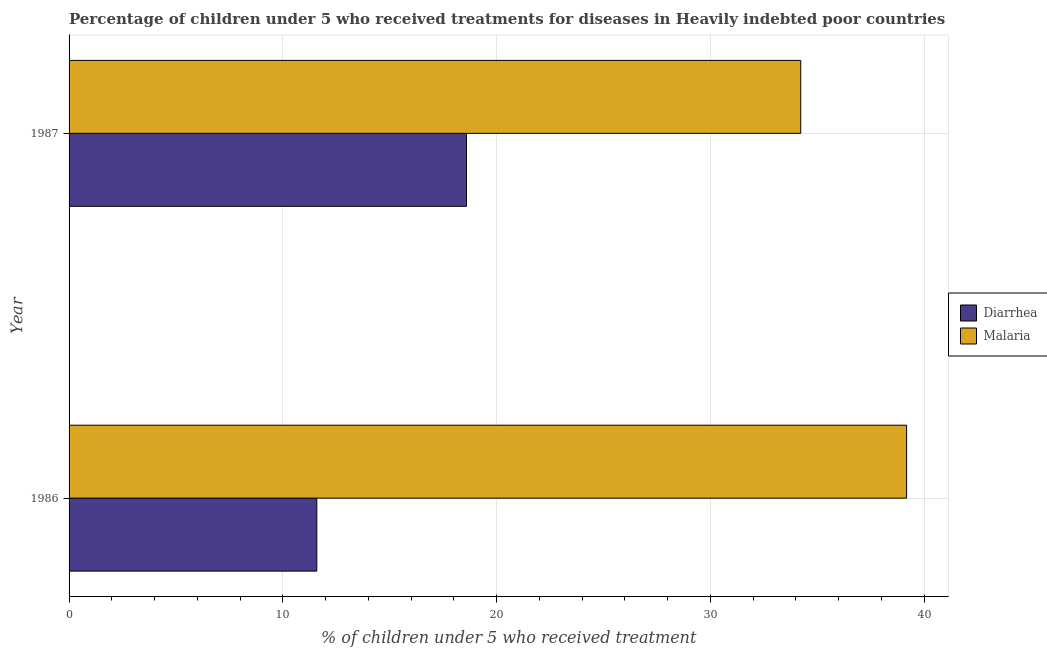How many different coloured bars are there?
Give a very brief answer. 2. How many groups of bars are there?
Make the answer very short. 2. Are the number of bars per tick equal to the number of legend labels?
Keep it short and to the point. Yes. Are the number of bars on each tick of the Y-axis equal?
Make the answer very short. Yes. How many bars are there on the 2nd tick from the top?
Keep it short and to the point. 2. In how many cases, is the number of bars for a given year not equal to the number of legend labels?
Your answer should be compact. 0. What is the percentage of children who received treatment for diarrhoea in 1987?
Your answer should be very brief. 18.59. Across all years, what is the maximum percentage of children who received treatment for malaria?
Your answer should be compact. 39.18. Across all years, what is the minimum percentage of children who received treatment for diarrhoea?
Your answer should be very brief. 11.59. In which year was the percentage of children who received treatment for diarrhoea maximum?
Ensure brevity in your answer.  1987. In which year was the percentage of children who received treatment for diarrhoea minimum?
Give a very brief answer. 1986. What is the total percentage of children who received treatment for malaria in the graph?
Provide a succinct answer. 73.4. What is the difference between the percentage of children who received treatment for malaria in 1986 and that in 1987?
Your answer should be very brief. 4.95. What is the difference between the percentage of children who received treatment for diarrhoea in 1987 and the percentage of children who received treatment for malaria in 1986?
Provide a short and direct response. -20.59. What is the average percentage of children who received treatment for diarrhoea per year?
Ensure brevity in your answer.  15.09. In the year 1986, what is the difference between the percentage of children who received treatment for diarrhoea and percentage of children who received treatment for malaria?
Offer a terse response. -27.59. What is the ratio of the percentage of children who received treatment for malaria in 1986 to that in 1987?
Give a very brief answer. 1.15. What does the 1st bar from the top in 1986 represents?
Ensure brevity in your answer.  Malaria. What does the 1st bar from the bottom in 1987 represents?
Your response must be concise. Diarrhea. How many years are there in the graph?
Your answer should be very brief. 2. Does the graph contain grids?
Your answer should be very brief. Yes. How many legend labels are there?
Ensure brevity in your answer.  2. How are the legend labels stacked?
Offer a terse response. Vertical. What is the title of the graph?
Your answer should be compact. Percentage of children under 5 who received treatments for diseases in Heavily indebted poor countries. What is the label or title of the X-axis?
Give a very brief answer. % of children under 5 who received treatment. What is the % of children under 5 who received treatment in Diarrhea in 1986?
Offer a very short reply. 11.59. What is the % of children under 5 who received treatment of Malaria in 1986?
Your answer should be very brief. 39.18. What is the % of children under 5 who received treatment of Diarrhea in 1987?
Your answer should be compact. 18.59. What is the % of children under 5 who received treatment of Malaria in 1987?
Offer a terse response. 34.22. Across all years, what is the maximum % of children under 5 who received treatment in Diarrhea?
Provide a succinct answer. 18.59. Across all years, what is the maximum % of children under 5 who received treatment of Malaria?
Offer a very short reply. 39.18. Across all years, what is the minimum % of children under 5 who received treatment of Diarrhea?
Keep it short and to the point. 11.59. Across all years, what is the minimum % of children under 5 who received treatment in Malaria?
Provide a short and direct response. 34.22. What is the total % of children under 5 who received treatment of Diarrhea in the graph?
Make the answer very short. 30.17. What is the total % of children under 5 who received treatment of Malaria in the graph?
Your answer should be compact. 73.4. What is the difference between the % of children under 5 who received treatment in Diarrhea in 1986 and that in 1987?
Make the answer very short. -7. What is the difference between the % of children under 5 who received treatment of Malaria in 1986 and that in 1987?
Your answer should be very brief. 4.95. What is the difference between the % of children under 5 who received treatment of Diarrhea in 1986 and the % of children under 5 who received treatment of Malaria in 1987?
Offer a very short reply. -22.64. What is the average % of children under 5 who received treatment in Diarrhea per year?
Your response must be concise. 15.09. What is the average % of children under 5 who received treatment of Malaria per year?
Provide a short and direct response. 36.7. In the year 1986, what is the difference between the % of children under 5 who received treatment of Diarrhea and % of children under 5 who received treatment of Malaria?
Your answer should be compact. -27.59. In the year 1987, what is the difference between the % of children under 5 who received treatment in Diarrhea and % of children under 5 who received treatment in Malaria?
Keep it short and to the point. -15.64. What is the ratio of the % of children under 5 who received treatment in Diarrhea in 1986 to that in 1987?
Provide a succinct answer. 0.62. What is the ratio of the % of children under 5 who received treatment of Malaria in 1986 to that in 1987?
Make the answer very short. 1.14. What is the difference between the highest and the second highest % of children under 5 who received treatment of Diarrhea?
Ensure brevity in your answer.  7. What is the difference between the highest and the second highest % of children under 5 who received treatment of Malaria?
Provide a succinct answer. 4.95. What is the difference between the highest and the lowest % of children under 5 who received treatment in Diarrhea?
Provide a short and direct response. 7. What is the difference between the highest and the lowest % of children under 5 who received treatment of Malaria?
Provide a succinct answer. 4.95. 